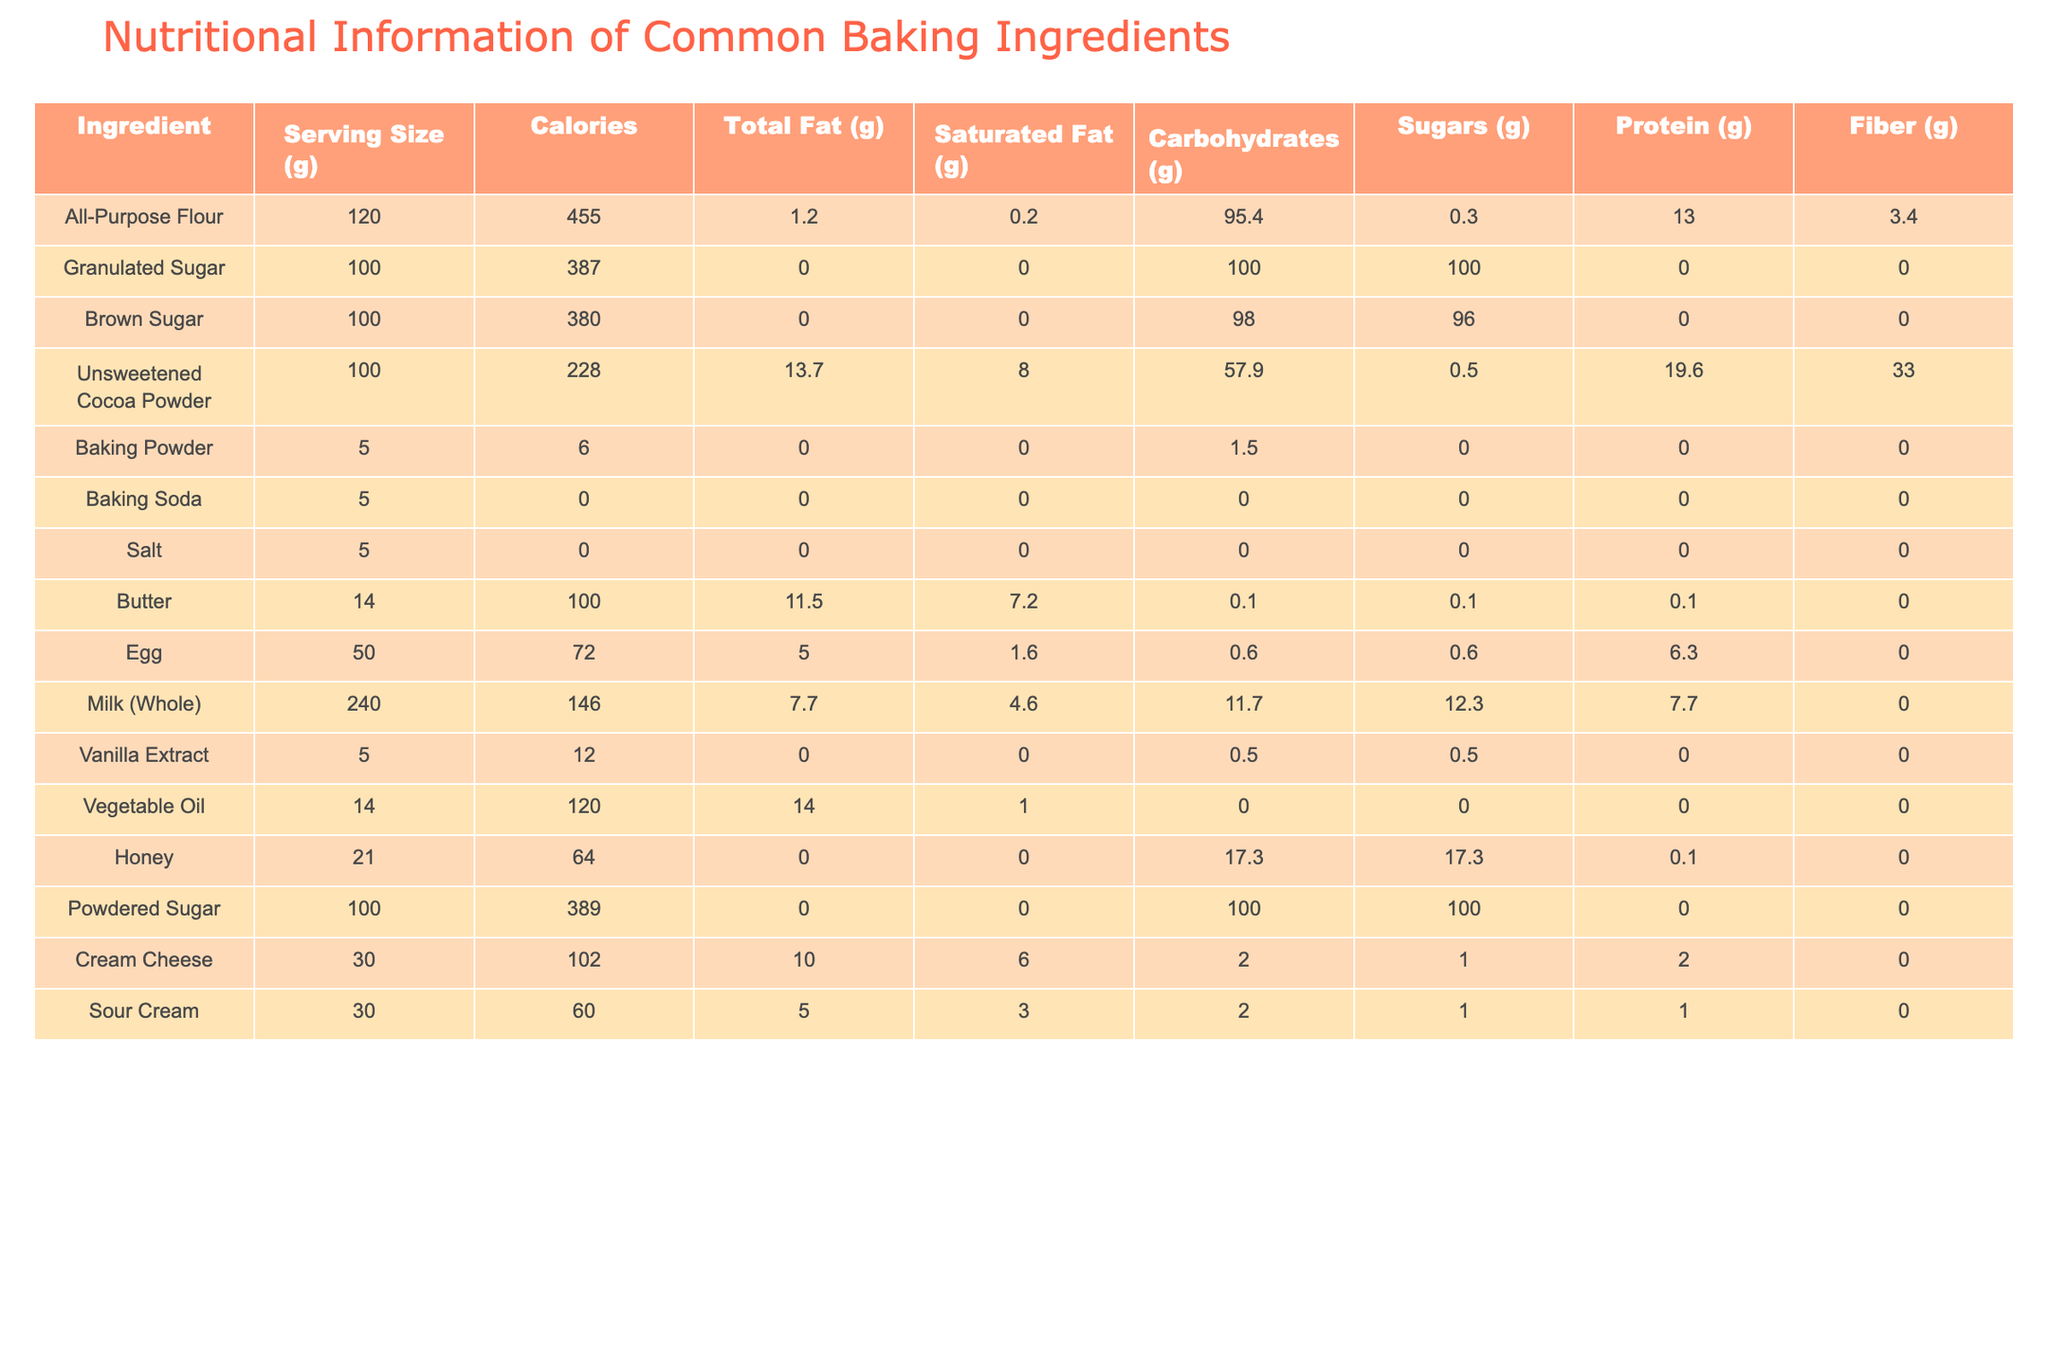What is the serving size of All-Purpose Flour? The serving size is specified in the table under the "Serving Size (g)" column for All-Purpose Flour. It shows 120 grams.
Answer: 120 g How many calories are in a serving of Unsweetened Cocoa Powder? The table lists the calories for Unsweetened Cocoa Powder in the "Calories" column, which is 228 calories per 100 grams.
Answer: 228 calories Does Granulated Sugar contain any protein? Checking the "Protein (g)" column for Granulated Sugar reveals that it has 0.0 grams of protein.
Answer: No What is the difference in total fat between Butter and Vegetable Oil? First, find the total fat in Butter (11.5 g) and Vegetable Oil (14.0 g) from their respective rows. The difference is calculated as 14.0 g - 11.5 g = 2.5 g.
Answer: 2.5 g If I use 100 g of Brown Sugar, what percentage of its weight is sugars? The "Sugars (g)" value for Brown Sugar is 96.0 g. To find the percentage: (96.0 g / 100 g) * 100 = 96%.
Answer: 96% What is the total carbohydrate content of Milk and Egg combined? The carbohydrate content for Milk is 11.7 g and for Egg is 0.6 g. Adding them together gives: 11.7 g + 0.6 g = 12.3 g of carbohydrates combined.
Answer: 12.3 g Which ingredient has the highest amount of fiber per serving? By comparing the "Fiber (g)" values, Unsweetened Cocoa Powder has the highest at 33.0 g.
Answer: Unsweetened Cocoa Powder What is the average calorie content of the ingredients that contain fats? The total calories for Butter (100), Vegetable Oil (120), and Unsweetened Cocoa Powder (228) are summed: 100 + 120 + 228 = 448. There are three ingredients, so the average is 448 / 3 = 149.33 calories.
Answer: 149.33 calories How many grams of saturated fat does Sour Cream contain? Looking at the "Saturated Fat (g)" column for Sour Cream, it shows 3.0 g of saturated fat.
Answer: 3.0 g If I replace the required 14 g of butter with honey, how many calories does that change represent? Butter has 100 calories per 14 g, and honey has 64 calories per 21 g. The total calories for 14 g of honey can be scaled as (64 / 21) * 14 ≈ 42.67 calories. The difference in calories when using honey is approximately 100 - 42.67 = 57.33 calories less.
Answer: 57.33 calories less 